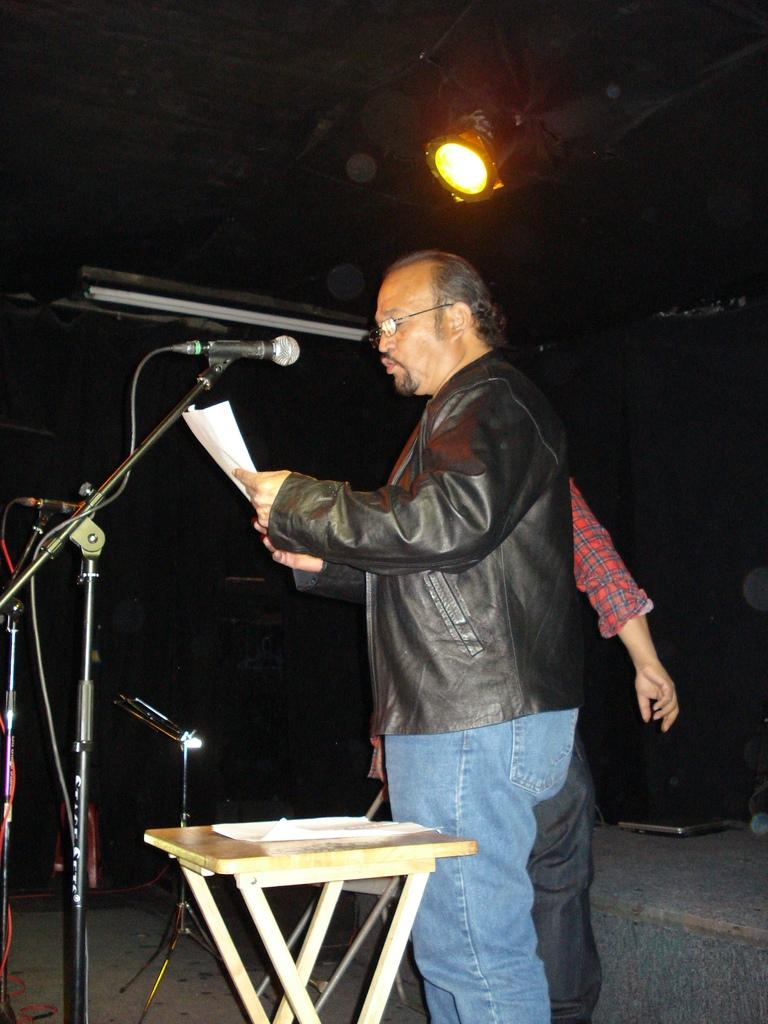What is the main subject of the image? There is a person standing in the image. Can you describe the clothing of the person? The person is wearing a black jacket. Is there anyone else in the image? Yes, there is another person standing behind the first person. What can be seen on the table in the image? Papers are present on the table. What is the source of light in the image? There is a light on the top of the image. How many babies are visible in the image? There are no babies present in the image. What type of ticket is being used by the person in the image? There is no ticket visible in the image. 